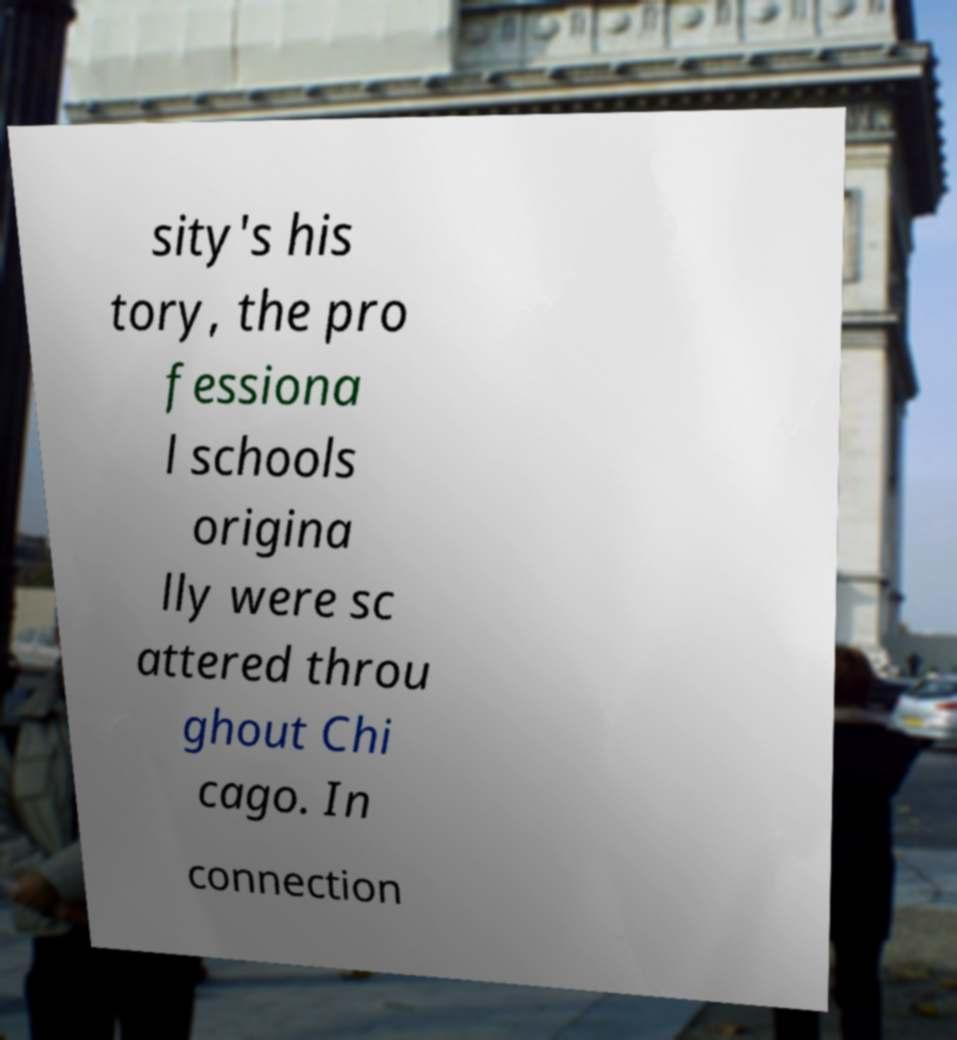Can you accurately transcribe the text from the provided image for me? sity's his tory, the pro fessiona l schools origina lly were sc attered throu ghout Chi cago. In connection 